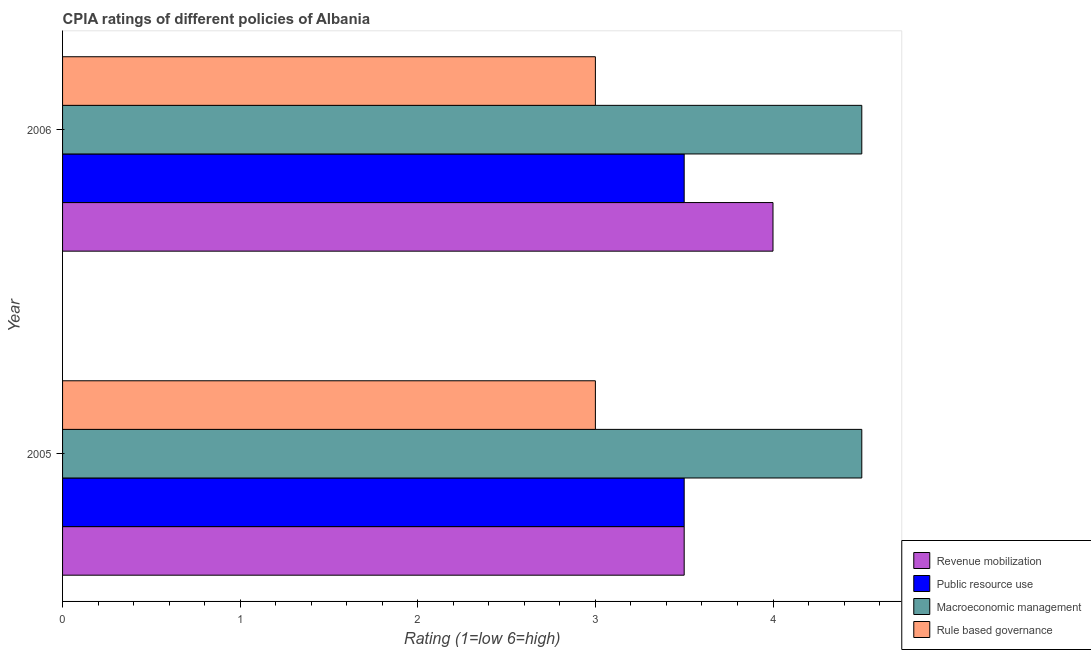How many different coloured bars are there?
Offer a very short reply. 4. How many groups of bars are there?
Keep it short and to the point. 2. Are the number of bars on each tick of the Y-axis equal?
Your response must be concise. Yes. How many bars are there on the 1st tick from the top?
Keep it short and to the point. 4. What is the label of the 1st group of bars from the top?
Give a very brief answer. 2006. In how many cases, is the number of bars for a given year not equal to the number of legend labels?
Provide a short and direct response. 0. Across all years, what is the maximum cpia rating of macroeconomic management?
Offer a terse response. 4.5. In which year was the cpia rating of revenue mobilization maximum?
Provide a short and direct response. 2006. In which year was the cpia rating of public resource use minimum?
Keep it short and to the point. 2005. What is the difference between the cpia rating of public resource use in 2006 and the cpia rating of rule based governance in 2005?
Give a very brief answer. 0.5. In the year 2005, what is the difference between the cpia rating of rule based governance and cpia rating of revenue mobilization?
Give a very brief answer. -0.5. In how many years, is the cpia rating of rule based governance greater than the average cpia rating of rule based governance taken over all years?
Your answer should be very brief. 0. Is it the case that in every year, the sum of the cpia rating of public resource use and cpia rating of macroeconomic management is greater than the sum of cpia rating of revenue mobilization and cpia rating of rule based governance?
Offer a very short reply. Yes. What does the 4th bar from the top in 2006 represents?
Provide a short and direct response. Revenue mobilization. What does the 1st bar from the bottom in 2006 represents?
Your answer should be very brief. Revenue mobilization. Is it the case that in every year, the sum of the cpia rating of revenue mobilization and cpia rating of public resource use is greater than the cpia rating of macroeconomic management?
Provide a succinct answer. Yes. How many bars are there?
Provide a short and direct response. 8. Are all the bars in the graph horizontal?
Keep it short and to the point. Yes. What is the difference between two consecutive major ticks on the X-axis?
Make the answer very short. 1. Does the graph contain any zero values?
Your answer should be very brief. No. Does the graph contain grids?
Provide a short and direct response. No. How many legend labels are there?
Provide a short and direct response. 4. How are the legend labels stacked?
Ensure brevity in your answer.  Vertical. What is the title of the graph?
Offer a terse response. CPIA ratings of different policies of Albania. What is the Rating (1=low 6=high) of Public resource use in 2005?
Provide a succinct answer. 3.5. What is the Rating (1=low 6=high) of Macroeconomic management in 2005?
Give a very brief answer. 4.5. What is the Rating (1=low 6=high) of Revenue mobilization in 2006?
Your response must be concise. 4. What is the Rating (1=low 6=high) of Macroeconomic management in 2006?
Give a very brief answer. 4.5. What is the Rating (1=low 6=high) of Rule based governance in 2006?
Offer a very short reply. 3. Across all years, what is the maximum Rating (1=low 6=high) of Macroeconomic management?
Make the answer very short. 4.5. Across all years, what is the maximum Rating (1=low 6=high) of Rule based governance?
Provide a succinct answer. 3. Across all years, what is the minimum Rating (1=low 6=high) in Public resource use?
Give a very brief answer. 3.5. Across all years, what is the minimum Rating (1=low 6=high) of Macroeconomic management?
Offer a very short reply. 4.5. What is the total Rating (1=low 6=high) of Revenue mobilization in the graph?
Your response must be concise. 7.5. What is the total Rating (1=low 6=high) of Public resource use in the graph?
Provide a succinct answer. 7. What is the difference between the Rating (1=low 6=high) in Public resource use in 2005 and that in 2006?
Give a very brief answer. 0. What is the difference between the Rating (1=low 6=high) of Rule based governance in 2005 and that in 2006?
Your response must be concise. 0. What is the difference between the Rating (1=low 6=high) of Revenue mobilization in 2005 and the Rating (1=low 6=high) of Macroeconomic management in 2006?
Make the answer very short. -1. What is the difference between the Rating (1=low 6=high) of Public resource use in 2005 and the Rating (1=low 6=high) of Macroeconomic management in 2006?
Your response must be concise. -1. What is the difference between the Rating (1=low 6=high) of Public resource use in 2005 and the Rating (1=low 6=high) of Rule based governance in 2006?
Offer a very short reply. 0.5. What is the average Rating (1=low 6=high) in Revenue mobilization per year?
Keep it short and to the point. 3.75. What is the average Rating (1=low 6=high) of Rule based governance per year?
Offer a terse response. 3. In the year 2005, what is the difference between the Rating (1=low 6=high) in Revenue mobilization and Rating (1=low 6=high) in Macroeconomic management?
Your response must be concise. -1. In the year 2005, what is the difference between the Rating (1=low 6=high) in Macroeconomic management and Rating (1=low 6=high) in Rule based governance?
Offer a very short reply. 1.5. In the year 2006, what is the difference between the Rating (1=low 6=high) of Revenue mobilization and Rating (1=low 6=high) of Public resource use?
Give a very brief answer. 0.5. In the year 2006, what is the difference between the Rating (1=low 6=high) in Revenue mobilization and Rating (1=low 6=high) in Macroeconomic management?
Ensure brevity in your answer.  -0.5. In the year 2006, what is the difference between the Rating (1=low 6=high) in Public resource use and Rating (1=low 6=high) in Macroeconomic management?
Provide a short and direct response. -1. In the year 2006, what is the difference between the Rating (1=low 6=high) of Public resource use and Rating (1=low 6=high) of Rule based governance?
Keep it short and to the point. 0.5. What is the ratio of the Rating (1=low 6=high) of Public resource use in 2005 to that in 2006?
Your response must be concise. 1. What is the ratio of the Rating (1=low 6=high) in Rule based governance in 2005 to that in 2006?
Your answer should be very brief. 1. What is the difference between the highest and the second highest Rating (1=low 6=high) in Public resource use?
Provide a succinct answer. 0. What is the difference between the highest and the lowest Rating (1=low 6=high) of Revenue mobilization?
Offer a terse response. 0.5. What is the difference between the highest and the lowest Rating (1=low 6=high) of Macroeconomic management?
Your response must be concise. 0. 